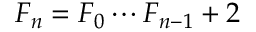<formula> <loc_0><loc_0><loc_500><loc_500>F _ { n } = F _ { 0 } \cdots F _ { n - 1 } + 2</formula> 